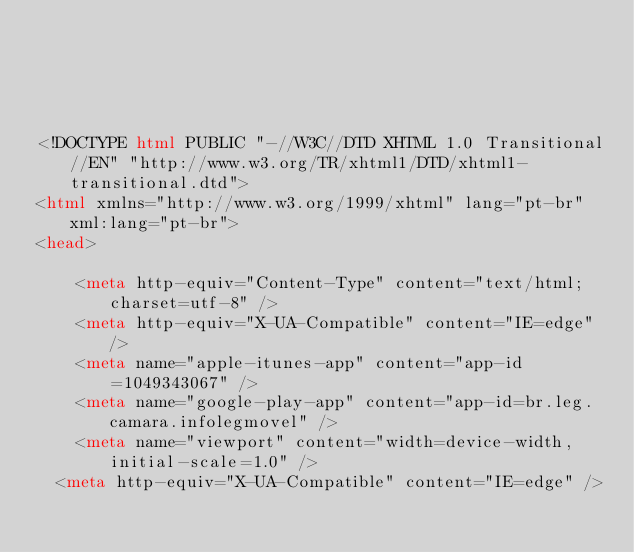Convert code to text. <code><loc_0><loc_0><loc_500><loc_500><_HTML_>




<!DOCTYPE html PUBLIC "-//W3C//DTD XHTML 1.0 Transitional//EN" "http://www.w3.org/TR/xhtml1/DTD/xhtml1-transitional.dtd">
<html xmlns="http://www.w3.org/1999/xhtml" lang="pt-br" xml:lang="pt-br">
<head>
	    
    <meta http-equiv="Content-Type" content="text/html; charset=utf-8" />
    <meta http-equiv="X-UA-Compatible" content="IE=edge" />
    <meta name="apple-itunes-app" content="app-id=1049343067" />
    <meta name="google-play-app" content="app-id=br.leg.camara.infolegmovel" />
    <meta name="viewport" content="width=device-width, initial-scale=1.0" />
	<meta http-equiv="X-UA-Compatible" content="IE=edge" /> 
    </code> 